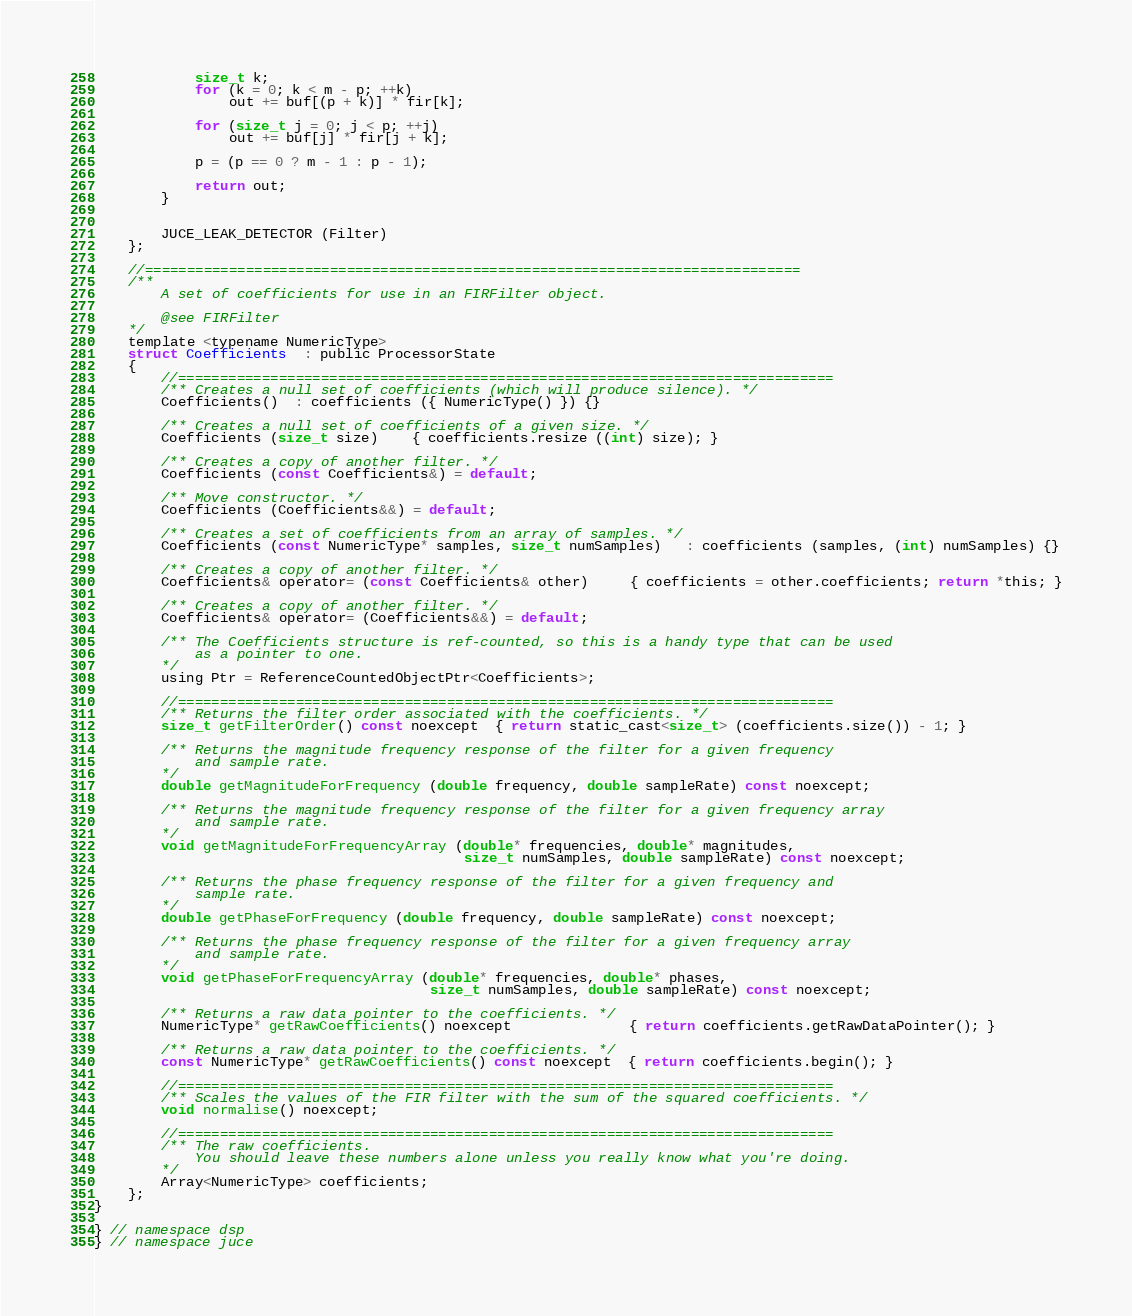Convert code to text. <code><loc_0><loc_0><loc_500><loc_500><_C_>
            size_t k;
            for (k = 0; k < m - p; ++k)
                out += buf[(p + k)] * fir[k];

            for (size_t j = 0; j < p; ++j)
                out += buf[j] * fir[j + k];

            p = (p == 0 ? m - 1 : p - 1);

            return out;
        }


        JUCE_LEAK_DETECTOR (Filter)
    };

    //==============================================================================
    /**
        A set of coefficients for use in an FIRFilter object.

        @see FIRFilter
    */
    template <typename NumericType>
    struct Coefficients  : public ProcessorState
    {
        //==============================================================================
        /** Creates a null set of coefficients (which will produce silence). */
        Coefficients()  : coefficients ({ NumericType() }) {}

        /** Creates a null set of coefficients of a given size. */
        Coefficients (size_t size)    { coefficients.resize ((int) size); }

        /** Creates a copy of another filter. */
        Coefficients (const Coefficients&) = default;

        /** Move constructor. */
        Coefficients (Coefficients&&) = default;

        /** Creates a set of coefficients from an array of samples. */
        Coefficients (const NumericType* samples, size_t numSamples)   : coefficients (samples, (int) numSamples) {}

        /** Creates a copy of another filter. */
        Coefficients& operator= (const Coefficients& other)     { coefficients = other.coefficients; return *this; }

        /** Creates a copy of another filter. */
        Coefficients& operator= (Coefficients&&) = default;

        /** The Coefficients structure is ref-counted, so this is a handy type that can be used
            as a pointer to one.
        */
        using Ptr = ReferenceCountedObjectPtr<Coefficients>;

        //==============================================================================
        /** Returns the filter order associated with the coefficients. */
        size_t getFilterOrder() const noexcept  { return static_cast<size_t> (coefficients.size()) - 1; }

        /** Returns the magnitude frequency response of the filter for a given frequency
            and sample rate.
        */
        double getMagnitudeForFrequency (double frequency, double sampleRate) const noexcept;

        /** Returns the magnitude frequency response of the filter for a given frequency array
            and sample rate.
        */
        void getMagnitudeForFrequencyArray (double* frequencies, double* magnitudes,
                                            size_t numSamples, double sampleRate) const noexcept;

        /** Returns the phase frequency response of the filter for a given frequency and
            sample rate.
        */
        double getPhaseForFrequency (double frequency, double sampleRate) const noexcept;

        /** Returns the phase frequency response of the filter for a given frequency array
            and sample rate.
        */
        void getPhaseForFrequencyArray (double* frequencies, double* phases,
                                        size_t numSamples, double sampleRate) const noexcept;

        /** Returns a raw data pointer to the coefficients. */
        NumericType* getRawCoefficients() noexcept              { return coefficients.getRawDataPointer(); }

        /** Returns a raw data pointer to the coefficients. */
        const NumericType* getRawCoefficients() const noexcept  { return coefficients.begin(); }

        //==============================================================================
        /** Scales the values of the FIR filter with the sum of the squared coefficients. */
        void normalise() noexcept;

        //==============================================================================
        /** The raw coefficients.
            You should leave these numbers alone unless you really know what you're doing.
        */
        Array<NumericType> coefficients;
    };
}

} // namespace dsp
} // namespace juce
</code> 